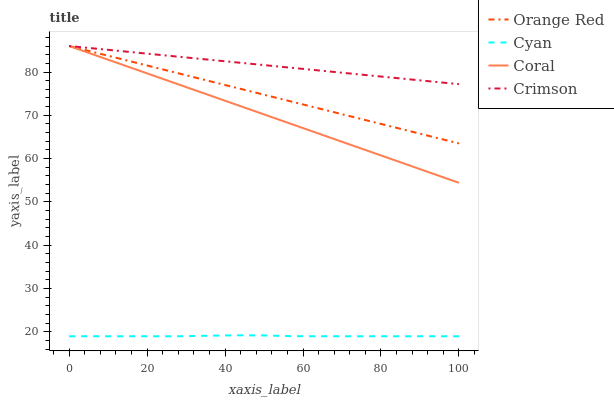Does Cyan have the minimum area under the curve?
Answer yes or no. Yes. Does Crimson have the maximum area under the curve?
Answer yes or no. Yes. Does Coral have the minimum area under the curve?
Answer yes or no. No. Does Coral have the maximum area under the curve?
Answer yes or no. No. Is Coral the smoothest?
Answer yes or no. Yes. Is Cyan the roughest?
Answer yes or no. Yes. Is Cyan the smoothest?
Answer yes or no. No. Is Coral the roughest?
Answer yes or no. No. Does Cyan have the lowest value?
Answer yes or no. Yes. Does Coral have the lowest value?
Answer yes or no. No. Does Orange Red have the highest value?
Answer yes or no. Yes. Does Cyan have the highest value?
Answer yes or no. No. Is Cyan less than Orange Red?
Answer yes or no. Yes. Is Crimson greater than Cyan?
Answer yes or no. Yes. Does Orange Red intersect Crimson?
Answer yes or no. Yes. Is Orange Red less than Crimson?
Answer yes or no. No. Is Orange Red greater than Crimson?
Answer yes or no. No. Does Cyan intersect Orange Red?
Answer yes or no. No. 